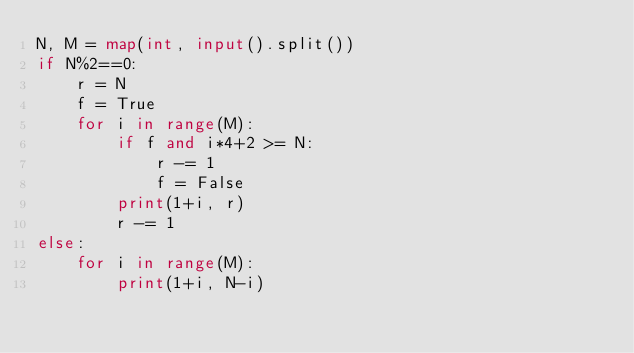Convert code to text. <code><loc_0><loc_0><loc_500><loc_500><_Python_>N, M = map(int, input().split())
if N%2==0:
    r = N
    f = True
    for i in range(M):
        if f and i*4+2 >= N:
            r -= 1
            f = False
        print(1+i, r)
        r -= 1
else:
    for i in range(M):
        print(1+i, N-i)
</code> 